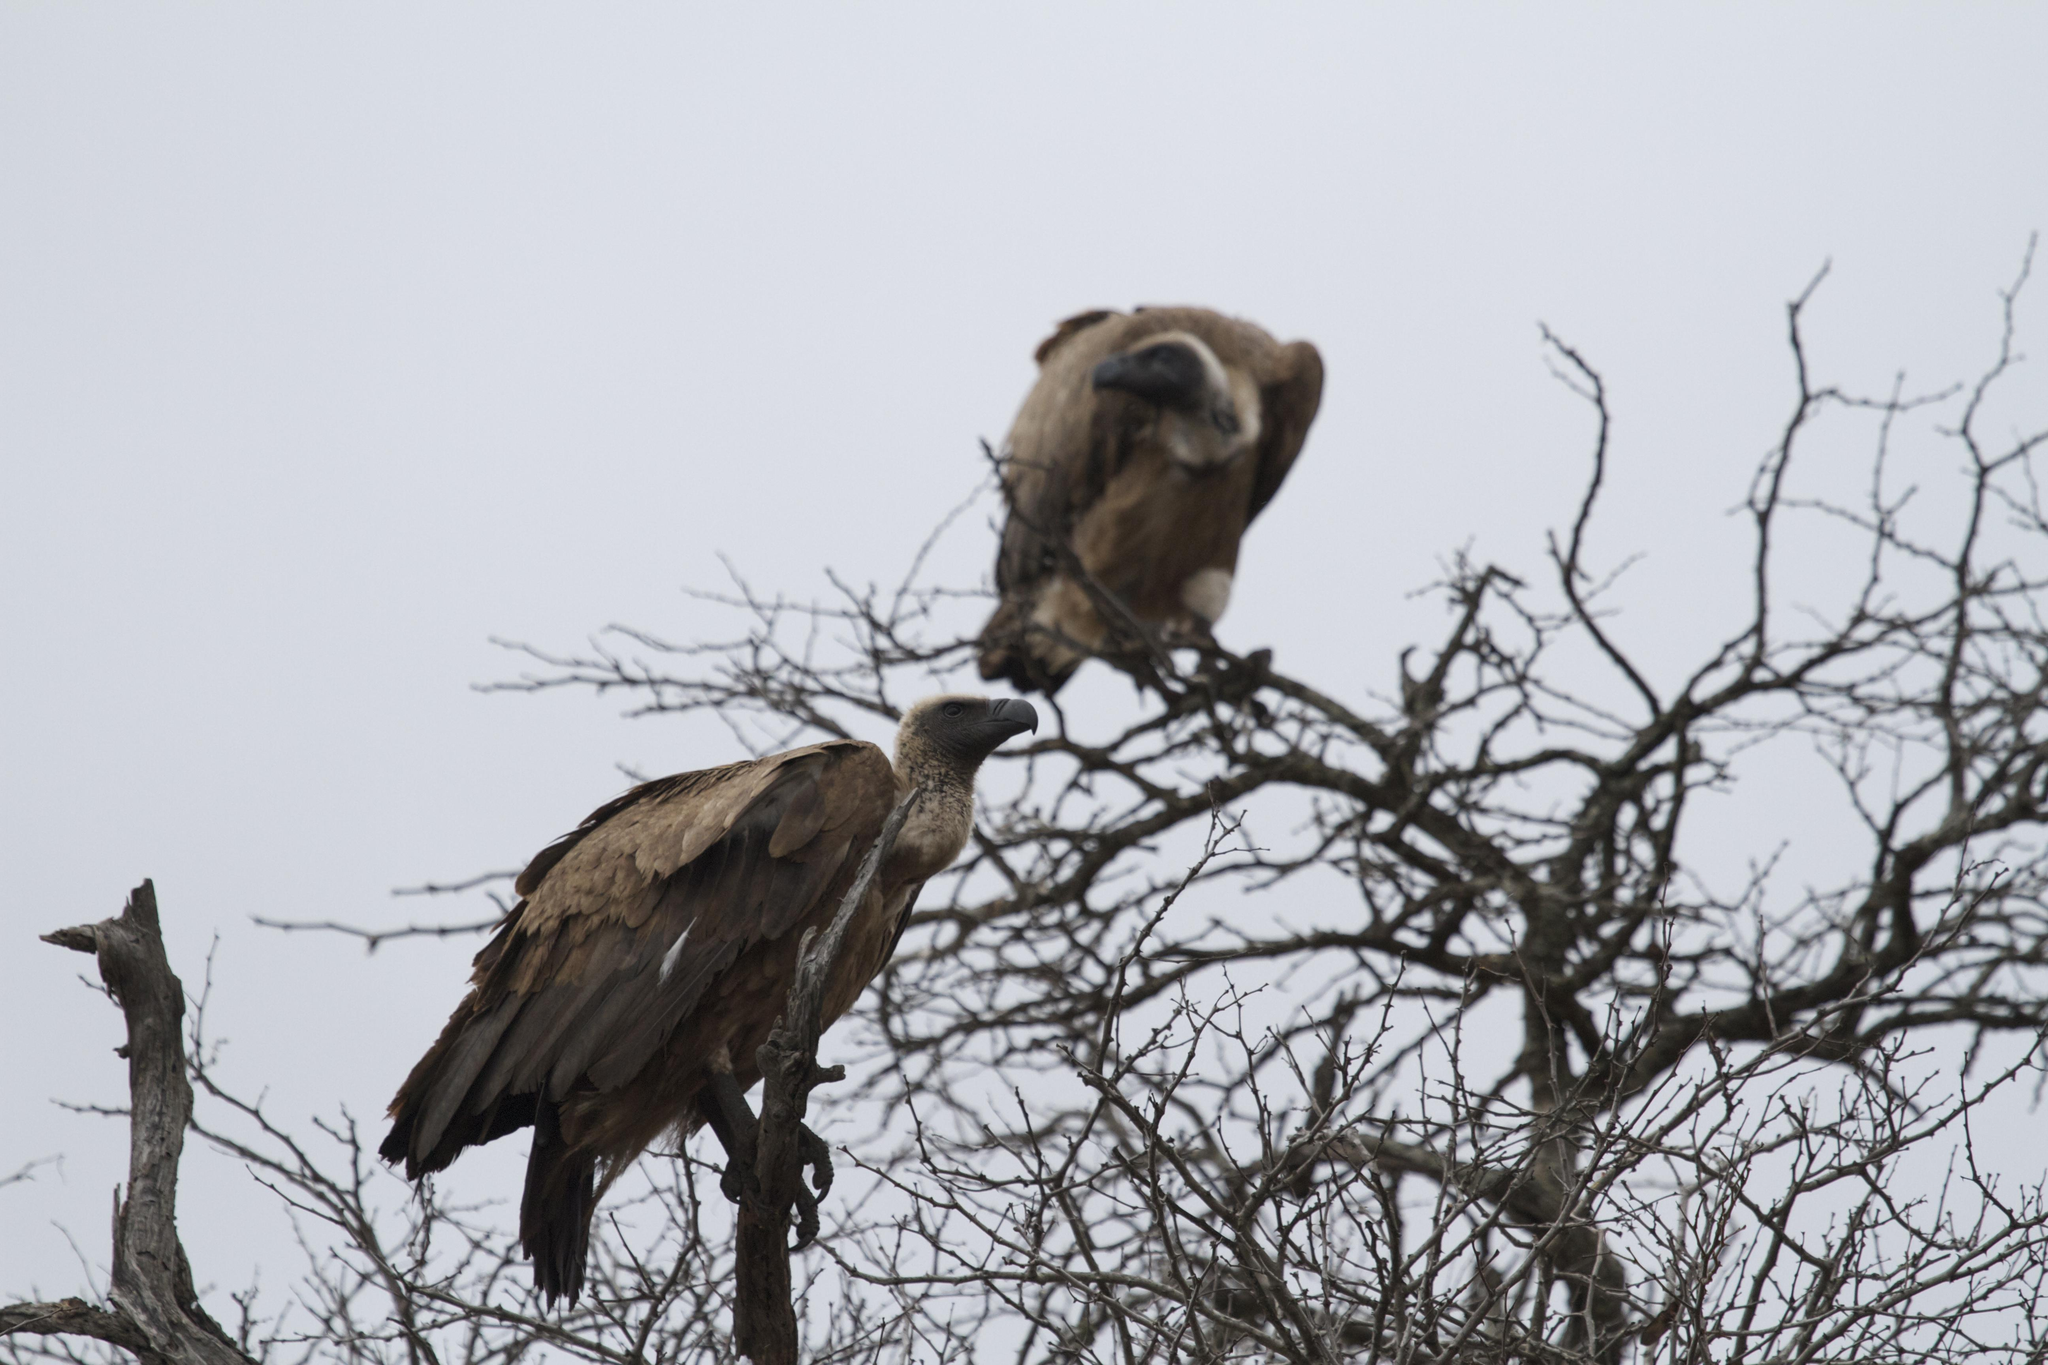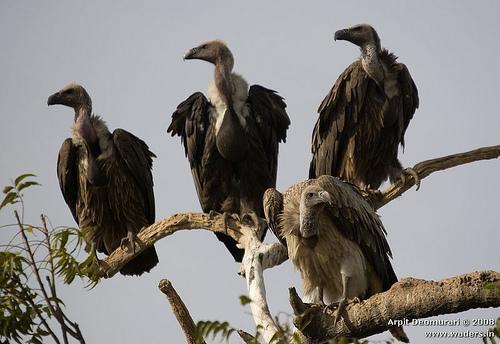The first image is the image on the left, the second image is the image on the right. For the images displayed, is the sentence "At least one of the birds has its wings spread." factually correct? Answer yes or no. No. 